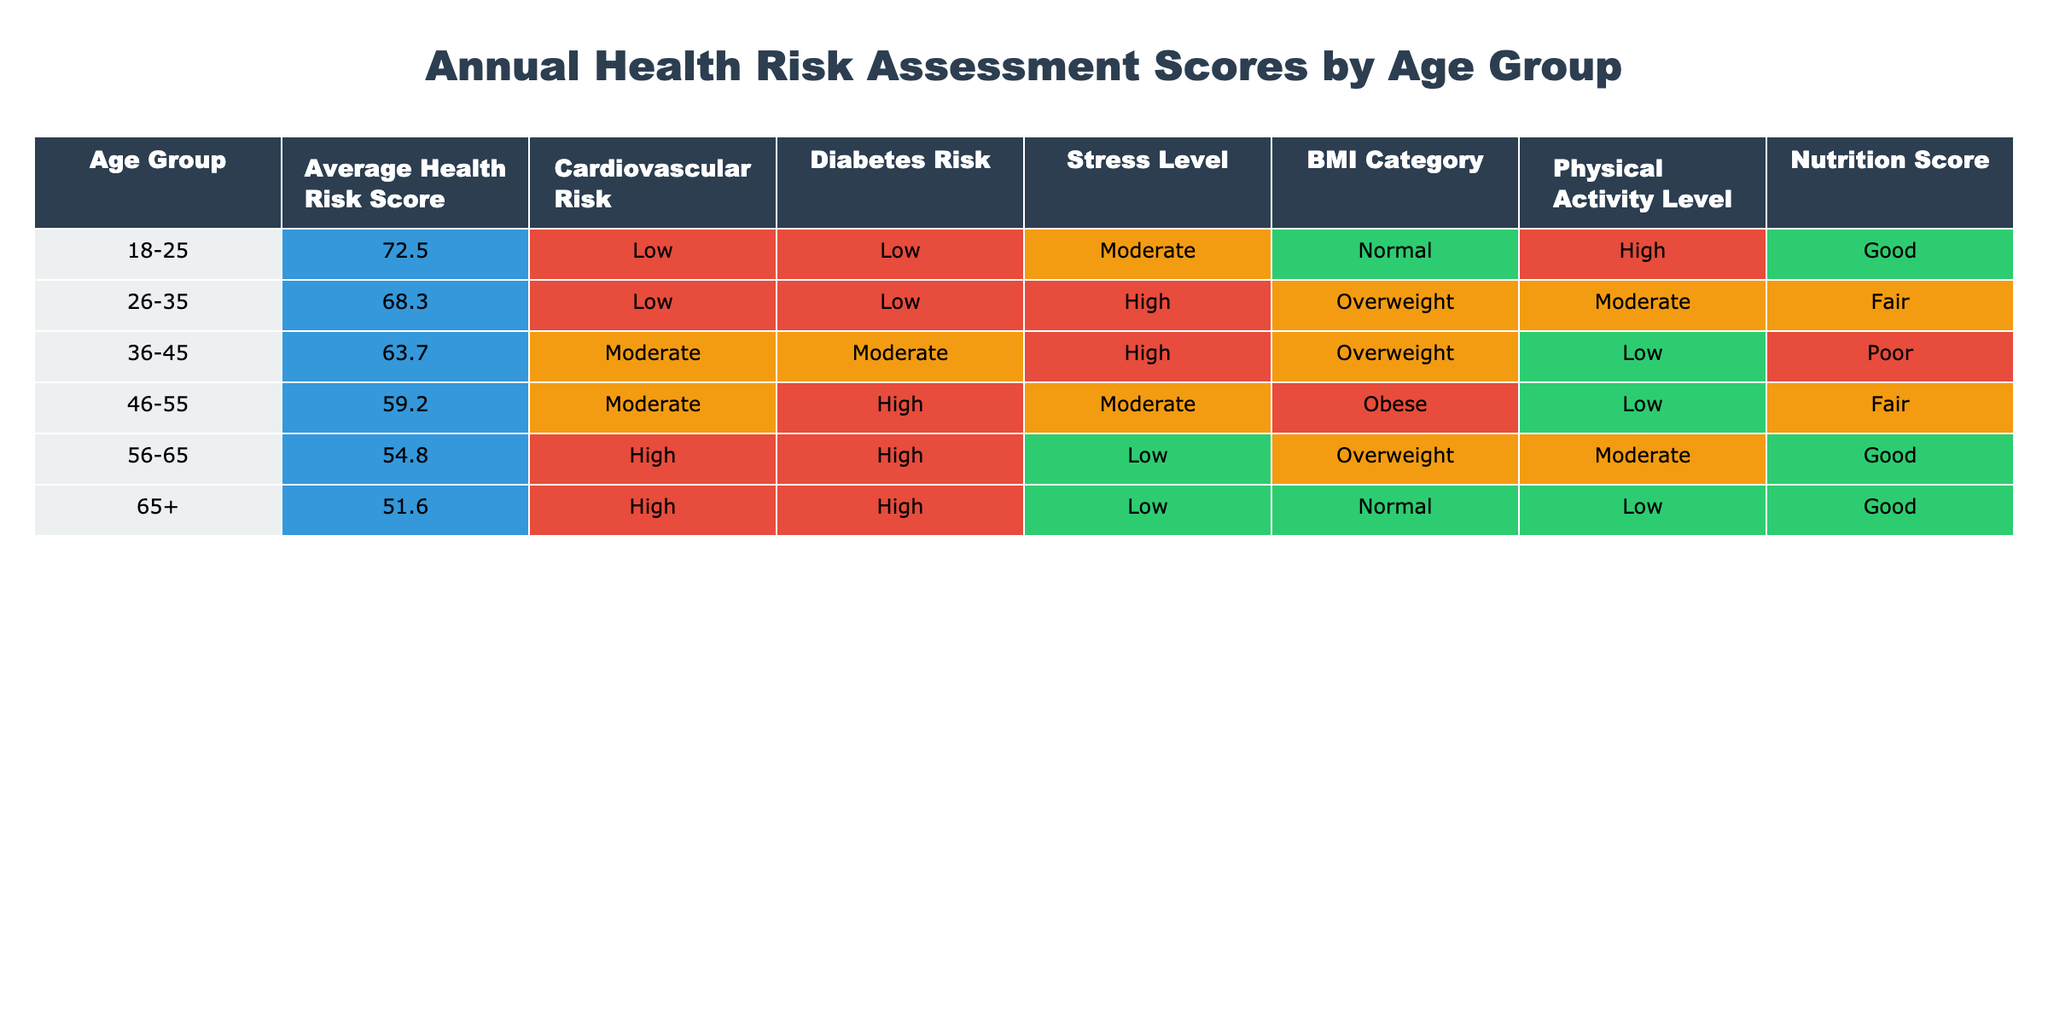What is the average health risk score for the age group 36-45? Looking at the table, the average health risk score for the age group 36-45 is listed directly in the corresponding cell, which shows 63.7.
Answer: 63.7 Which age group has the highest cardiovascular risk? In the table, the cardiovascular risk for each age group is indicated, and the age group 56-65 is marked as having the highest risk, categorized as "High."
Answer: 56-65 What is the nutrition score for the age group 46-55? The nutrition score for the age group 46-55 can be found in the table, where it is indicated as "Fair."
Answer: Fair Is the average health risk score higher for the age group 26-35 compared to 18-25? By comparing the data in the table, the average risk score for 26-35 is 68.3 and for 18-25 is 72.5. Since 68.3 is less than 72.5, the average score for 26-35 is not higher.
Answer: No What is the difference in average health risk scores between the age groups 65+ and 36-45? The average health risk score for 65+ is 51.6, and for 36-45, it is 63.7. The difference is calculated as 63.7 - 51.6 = 12.1.
Answer: 12.1 Which BMI category has the lowest average health risk score? By examining the BMI categories, the age group with "Obese" (46-55) has the lowest average health risk score of 59.2, indicating it as the lowest score for its category.
Answer: Obese What is the physical activity level for the age group 18-25? Referring directly to the table, the physical activity level for the age group 18-25 is noted as "High."
Answer: High Are stress levels lower in the 56-65 age group compared to the 46-55 age group? The stress levels for 56-65 are listed as "Low," whereas for 46-55 they are "Moderate." Since Low is lower than Moderate, the statement is true.
Answer: Yes What is the average health risk score for the age group 46-55 compared to the average health risk score for the age group 56-65? The average health risk score for 46-55 is 59.2 and for 56-65 is 54.8. Since 59.2 is greater than 54.8, the average for 46-55 is higher.
Answer: Higher What percentage of age groups have a low cardiovascular risk? The table shows that the age groups 18-25 and 26-35 have a "Low" cardiovascular risk. There are a total of 6 age groups presented, and 2 of them have low risk, so the percentage is (2/6) * 100 = 33.33%.
Answer: 33.33% 